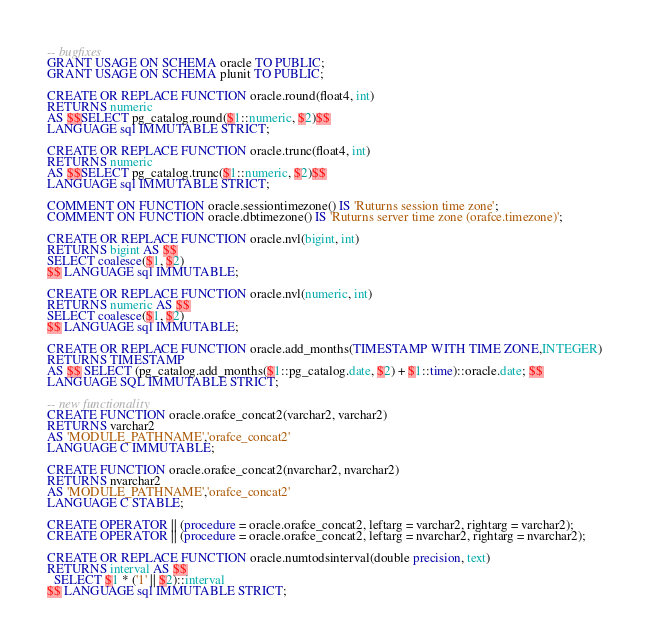Convert code to text. <code><loc_0><loc_0><loc_500><loc_500><_SQL_>-- bugfixes
GRANT USAGE ON SCHEMA oracle TO PUBLIC;
GRANT USAGE ON SCHEMA plunit TO PUBLIC;

CREATE OR REPLACE FUNCTION oracle.round(float4, int)
RETURNS numeric
AS $$SELECT pg_catalog.round($1::numeric, $2)$$
LANGUAGE sql IMMUTABLE STRICT;

CREATE OR REPLACE FUNCTION oracle.trunc(float4, int)
RETURNS numeric
AS $$SELECT pg_catalog.trunc($1::numeric, $2)$$
LANGUAGE sql IMMUTABLE STRICT;

COMMENT ON FUNCTION oracle.sessiontimezone() IS 'Ruturns session time zone';
COMMENT ON FUNCTION oracle.dbtimezone() IS 'Ruturns server time zone (orafce.timezone)';

CREATE OR REPLACE FUNCTION oracle.nvl(bigint, int)
RETURNS bigint AS $$
SELECT coalesce($1, $2)
$$ LANGUAGE sql IMMUTABLE;

CREATE OR REPLACE FUNCTION oracle.nvl(numeric, int)
RETURNS numeric AS $$
SELECT coalesce($1, $2)
$$ LANGUAGE sql IMMUTABLE;

CREATE OR REPLACE FUNCTION oracle.add_months(TIMESTAMP WITH TIME ZONE,INTEGER)
RETURNS TIMESTAMP
AS $$ SELECT (pg_catalog.add_months($1::pg_catalog.date, $2) + $1::time)::oracle.date; $$
LANGUAGE SQL IMMUTABLE STRICT;

-- new functionality
CREATE FUNCTION oracle.orafce_concat2(varchar2, varchar2)
RETURNS varchar2
AS 'MODULE_PATHNAME','orafce_concat2'
LANGUAGE C IMMUTABLE;

CREATE FUNCTION oracle.orafce_concat2(nvarchar2, nvarchar2)
RETURNS nvarchar2
AS 'MODULE_PATHNAME','orafce_concat2'
LANGUAGE C STABLE;

CREATE OPERATOR || (procedure = oracle.orafce_concat2, leftarg = varchar2, rightarg = varchar2);
CREATE OPERATOR || (procedure = oracle.orafce_concat2, leftarg = nvarchar2, rightarg = nvarchar2);

CREATE OR REPLACE FUNCTION oracle.numtodsinterval(double precision, text)
RETURNS interval AS $$
  SELECT $1 * ('1' || $2)::interval
$$ LANGUAGE sql IMMUTABLE STRICT;
</code> 